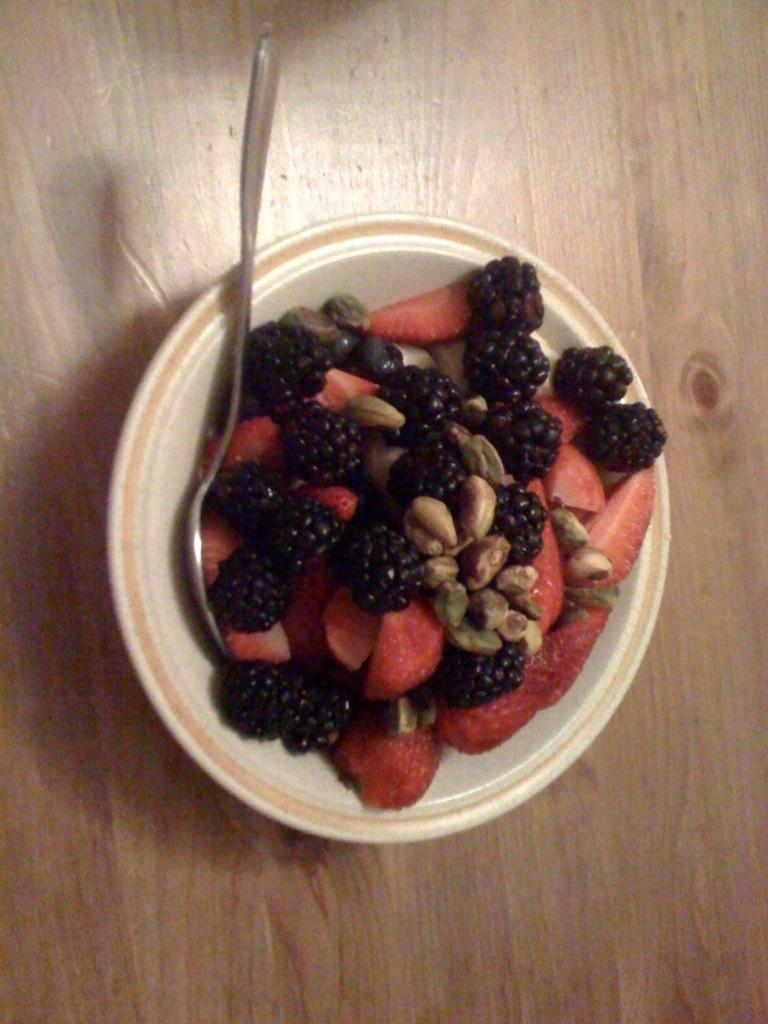What is located in the center of the image? There is a bowl in the center of the image. What is inside the bowl? The bowl contains fruits. What utensil is present in the bowl? There is a spoon in the bowl. What type of fog can be seen surrounding the car in the image? There is no car or fog present in the image; it features a bowl with fruits and a spoon. 